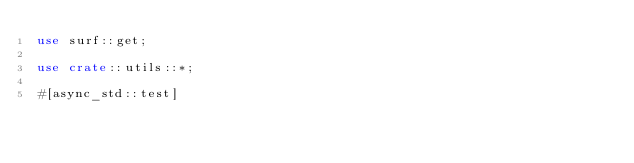Convert code to text. <code><loc_0><loc_0><loc_500><loc_500><_Rust_>use surf::get;

use crate::utils::*;

#[async_std::test]</code> 